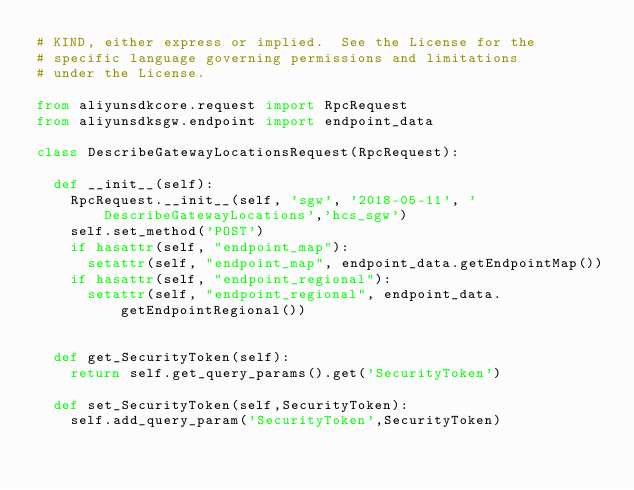<code> <loc_0><loc_0><loc_500><loc_500><_Python_># KIND, either express or implied.  See the License for the
# specific language governing permissions and limitations
# under the License.

from aliyunsdkcore.request import RpcRequest
from aliyunsdksgw.endpoint import endpoint_data

class DescribeGatewayLocationsRequest(RpcRequest):

	def __init__(self):
		RpcRequest.__init__(self, 'sgw', '2018-05-11', 'DescribeGatewayLocations','hcs_sgw')
		self.set_method('POST')
		if hasattr(self, "endpoint_map"):
			setattr(self, "endpoint_map", endpoint_data.getEndpointMap())
		if hasattr(self, "endpoint_regional"):
			setattr(self, "endpoint_regional", endpoint_data.getEndpointRegional())


	def get_SecurityToken(self):
		return self.get_query_params().get('SecurityToken')

	def set_SecurityToken(self,SecurityToken):
		self.add_query_param('SecurityToken',SecurityToken)</code> 